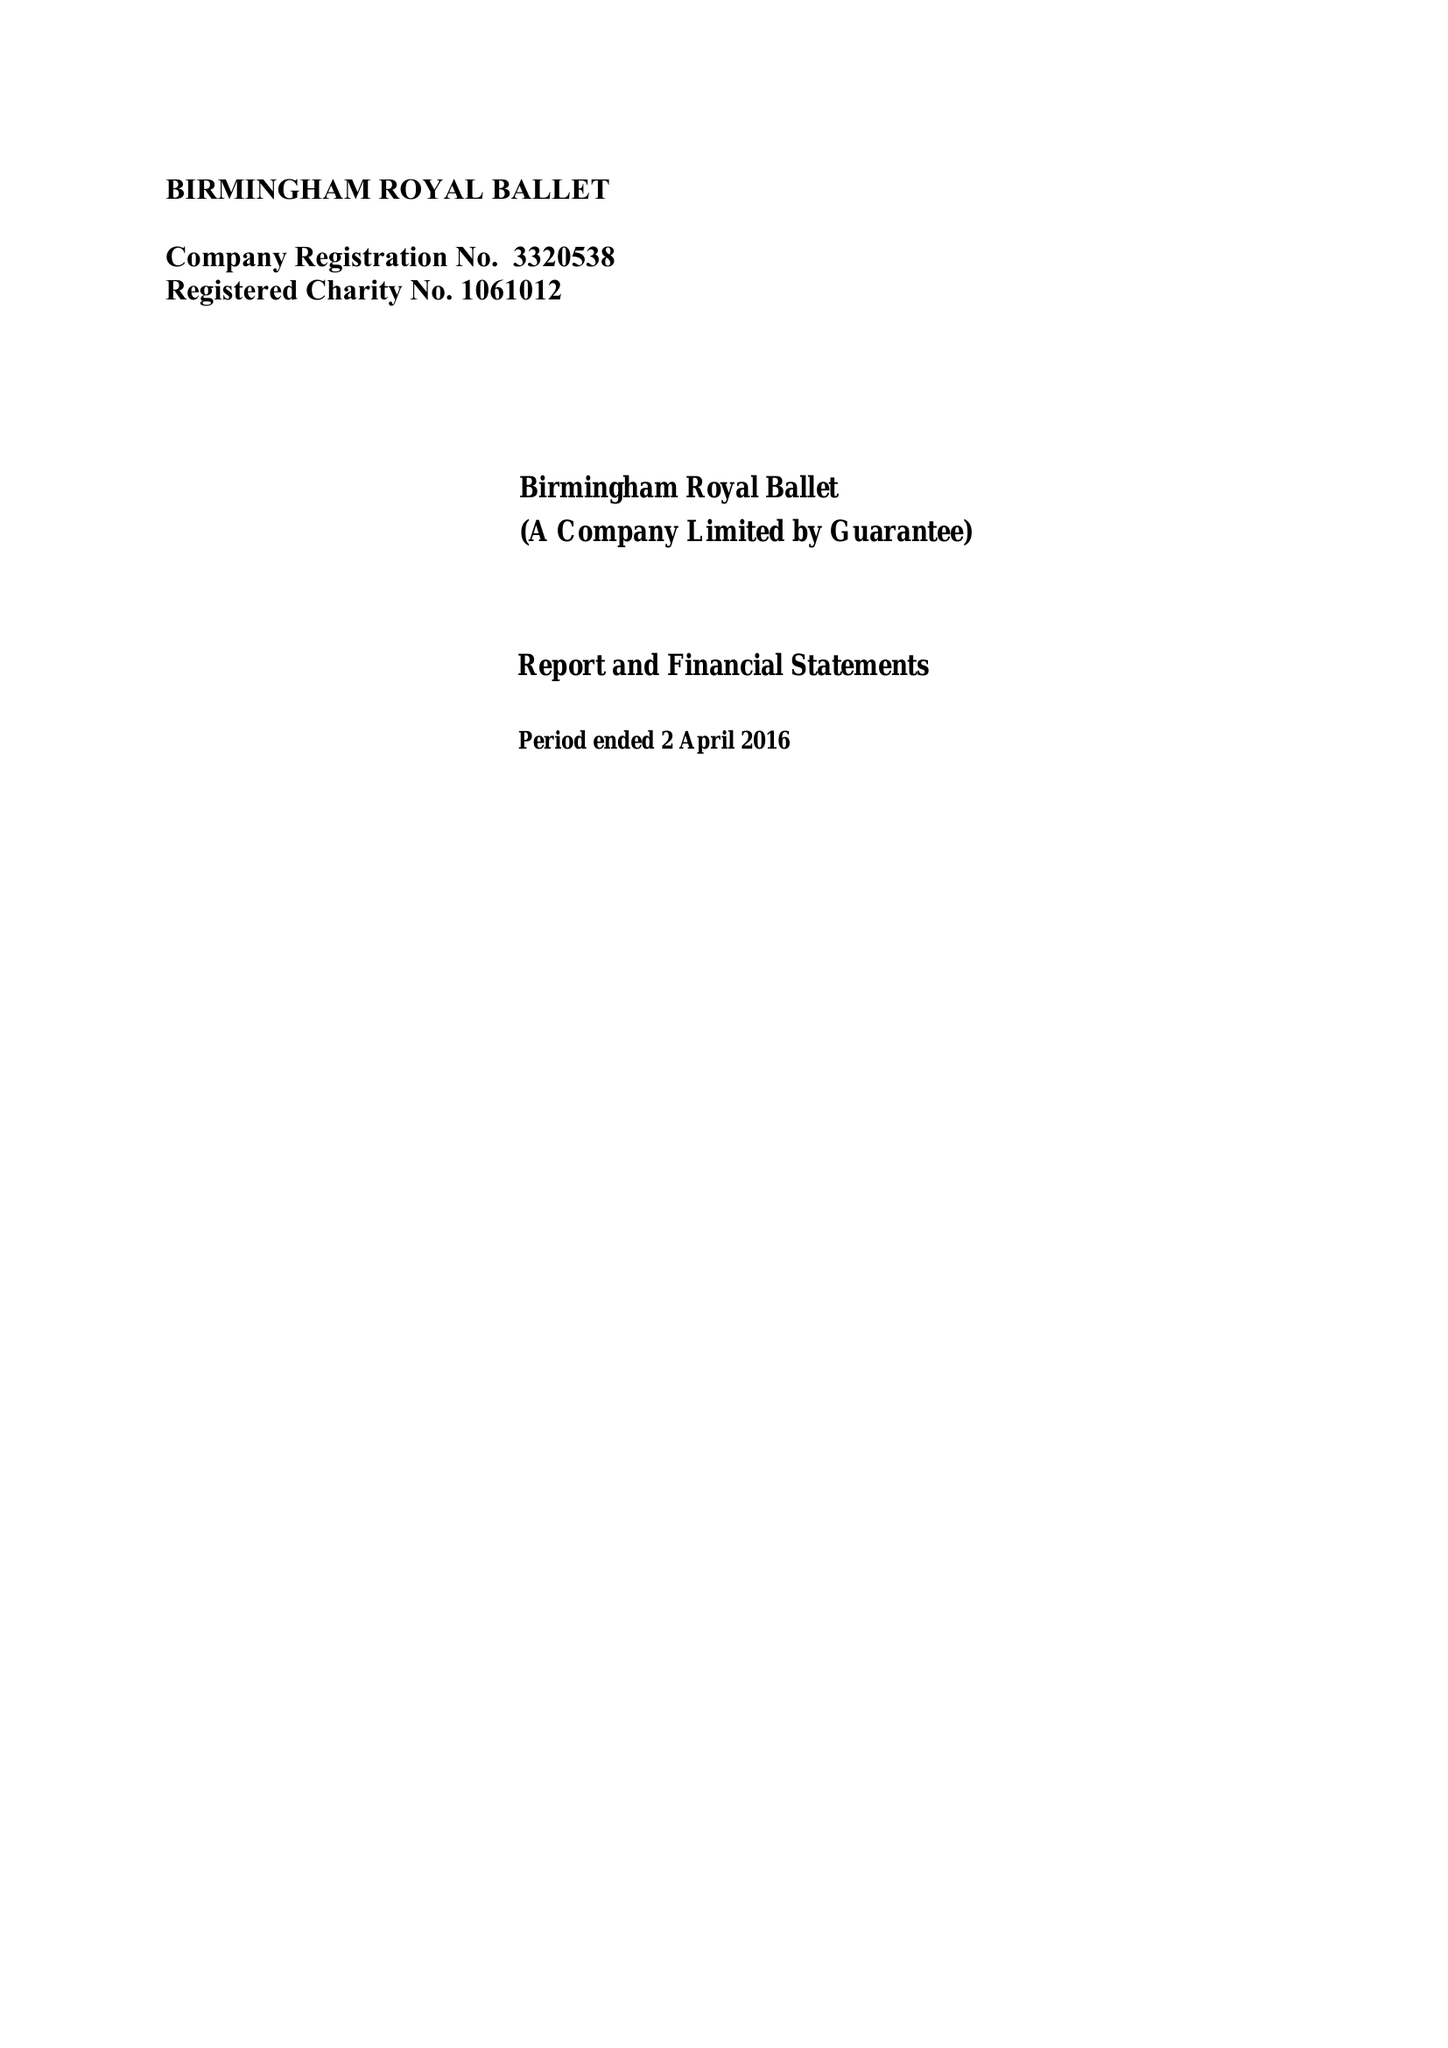What is the value for the income_annually_in_british_pounds?
Answer the question using a single word or phrase. 13976394.00 